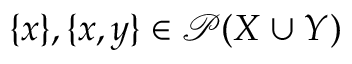Convert formula to latex. <formula><loc_0><loc_0><loc_500><loc_500>\{ x \} , \{ x , y \} \in { \mathcal { P } } ( X \cup Y )</formula> 